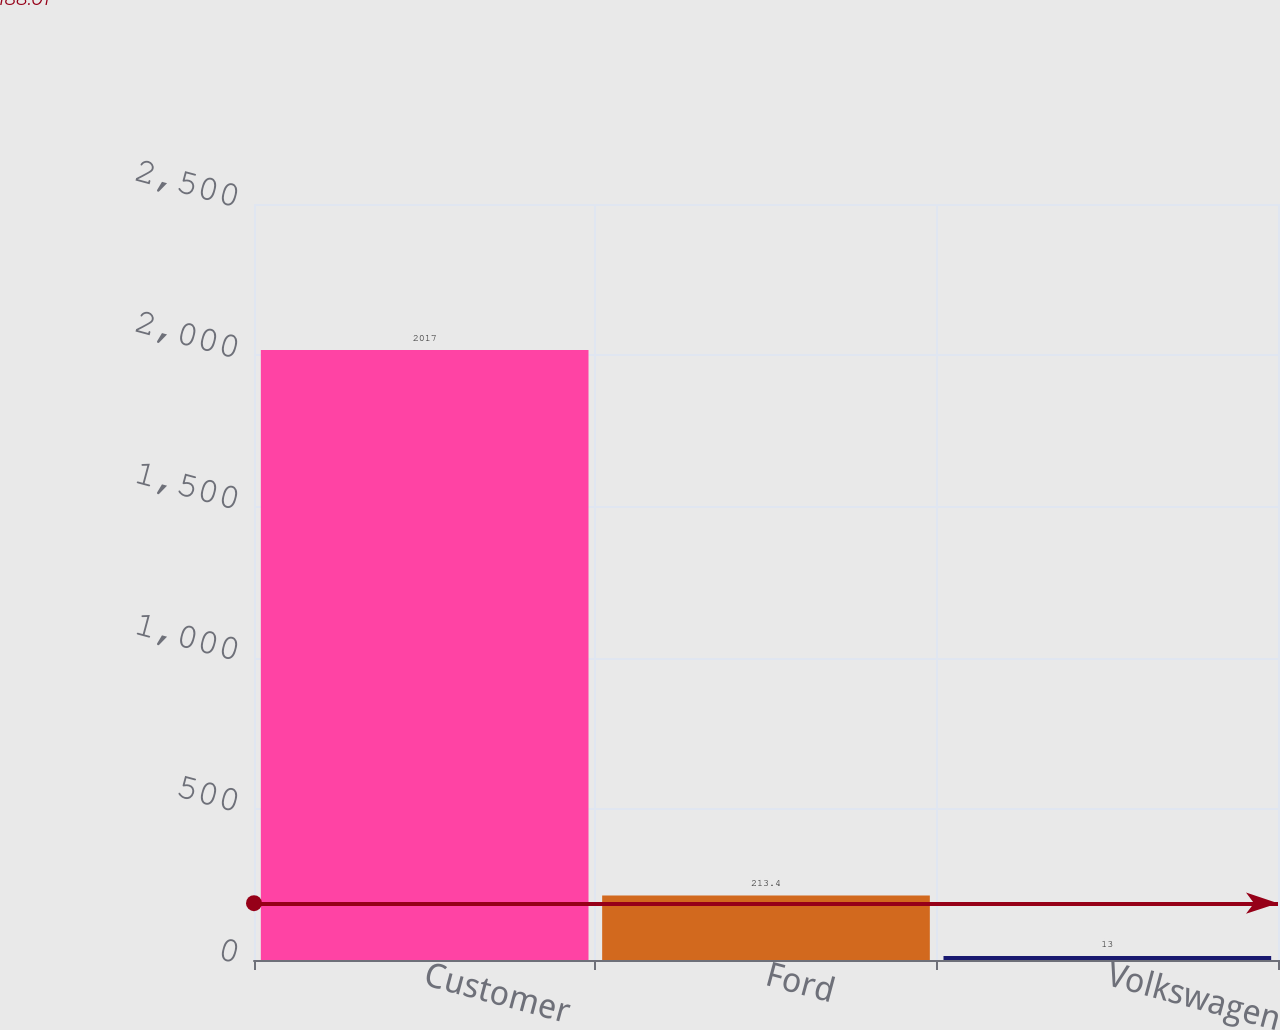Convert chart to OTSL. <chart><loc_0><loc_0><loc_500><loc_500><bar_chart><fcel>Customer<fcel>Ford<fcel>Volkswagen<nl><fcel>2017<fcel>213.4<fcel>13<nl></chart> 